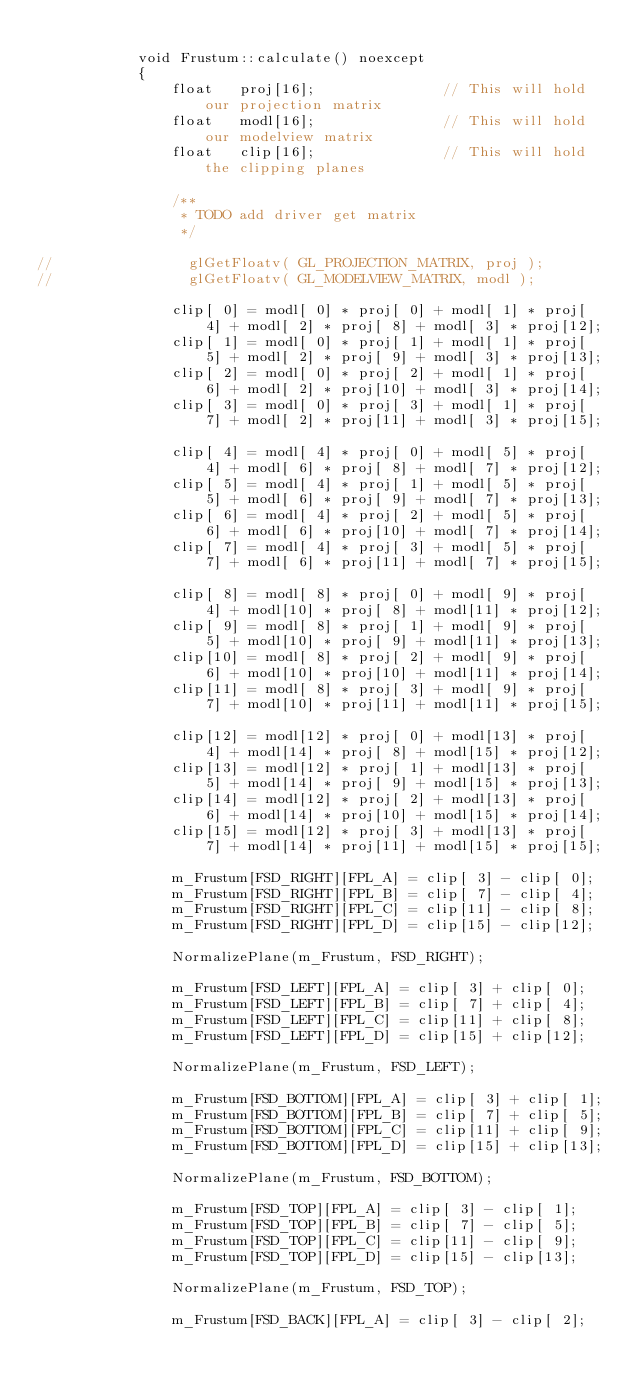Convert code to text. <code><loc_0><loc_0><loc_500><loc_500><_C++_>
            void Frustum::calculate() noexcept
            {
                float   proj[16];								// This will hold our projection matrix
                float   modl[16];								// This will hold our modelview matrix
                float   clip[16];								// This will hold the clipping planes

                /**
                 * TODO add driver get matrix
                 */

//                glGetFloatv( GL_PROJECTION_MATRIX, proj );
//                glGetFloatv( GL_MODELVIEW_MATRIX, modl );

                clip[ 0] = modl[ 0] * proj[ 0] + modl[ 1] * proj[ 4] + modl[ 2] * proj[ 8] + modl[ 3] * proj[12];
                clip[ 1] = modl[ 0] * proj[ 1] + modl[ 1] * proj[ 5] + modl[ 2] * proj[ 9] + modl[ 3] * proj[13];
                clip[ 2] = modl[ 0] * proj[ 2] + modl[ 1] * proj[ 6] + modl[ 2] * proj[10] + modl[ 3] * proj[14];
                clip[ 3] = modl[ 0] * proj[ 3] + modl[ 1] * proj[ 7] + modl[ 2] * proj[11] + modl[ 3] * proj[15];

                clip[ 4] = modl[ 4] * proj[ 0] + modl[ 5] * proj[ 4] + modl[ 6] * proj[ 8] + modl[ 7] * proj[12];
                clip[ 5] = modl[ 4] * proj[ 1] + modl[ 5] * proj[ 5] + modl[ 6] * proj[ 9] + modl[ 7] * proj[13];
                clip[ 6] = modl[ 4] * proj[ 2] + modl[ 5] * proj[ 6] + modl[ 6] * proj[10] + modl[ 7] * proj[14];
                clip[ 7] = modl[ 4] * proj[ 3] + modl[ 5] * proj[ 7] + modl[ 6] * proj[11] + modl[ 7] * proj[15];

                clip[ 8] = modl[ 8] * proj[ 0] + modl[ 9] * proj[ 4] + modl[10] * proj[ 8] + modl[11] * proj[12];
                clip[ 9] = modl[ 8] * proj[ 1] + modl[ 9] * proj[ 5] + modl[10] * proj[ 9] + modl[11] * proj[13];
                clip[10] = modl[ 8] * proj[ 2] + modl[ 9] * proj[ 6] + modl[10] * proj[10] + modl[11] * proj[14];
                clip[11] = modl[ 8] * proj[ 3] + modl[ 9] * proj[ 7] + modl[10] * proj[11] + modl[11] * proj[15];

                clip[12] = modl[12] * proj[ 0] + modl[13] * proj[ 4] + modl[14] * proj[ 8] + modl[15] * proj[12];
                clip[13] = modl[12] * proj[ 1] + modl[13] * proj[ 5] + modl[14] * proj[ 9] + modl[15] * proj[13];
                clip[14] = modl[12] * proj[ 2] + modl[13] * proj[ 6] + modl[14] * proj[10] + modl[15] * proj[14];
                clip[15] = modl[12] * proj[ 3] + modl[13] * proj[ 7] + modl[14] * proj[11] + modl[15] * proj[15];

                m_Frustum[FSD_RIGHT][FPL_A] = clip[ 3] - clip[ 0];
                m_Frustum[FSD_RIGHT][FPL_B] = clip[ 7] - clip[ 4];
                m_Frustum[FSD_RIGHT][FPL_C] = clip[11] - clip[ 8];
                m_Frustum[FSD_RIGHT][FPL_D] = clip[15] - clip[12];

                NormalizePlane(m_Frustum, FSD_RIGHT);

                m_Frustum[FSD_LEFT][FPL_A] = clip[ 3] + clip[ 0];
                m_Frustum[FSD_LEFT][FPL_B] = clip[ 7] + clip[ 4];
                m_Frustum[FSD_LEFT][FPL_C] = clip[11] + clip[ 8];
                m_Frustum[FSD_LEFT][FPL_D] = clip[15] + clip[12];

                NormalizePlane(m_Frustum, FSD_LEFT);

                m_Frustum[FSD_BOTTOM][FPL_A] = clip[ 3] + clip[ 1];
                m_Frustum[FSD_BOTTOM][FPL_B] = clip[ 7] + clip[ 5];
                m_Frustum[FSD_BOTTOM][FPL_C] = clip[11] + clip[ 9];
                m_Frustum[FSD_BOTTOM][FPL_D] = clip[15] + clip[13];

                NormalizePlane(m_Frustum, FSD_BOTTOM);

                m_Frustum[FSD_TOP][FPL_A] = clip[ 3] - clip[ 1];
                m_Frustum[FSD_TOP][FPL_B] = clip[ 7] - clip[ 5];
                m_Frustum[FSD_TOP][FPL_C] = clip[11] - clip[ 9];
                m_Frustum[FSD_TOP][FPL_D] = clip[15] - clip[13];

                NormalizePlane(m_Frustum, FSD_TOP);

                m_Frustum[FSD_BACK][FPL_A] = clip[ 3] - clip[ 2];</code> 